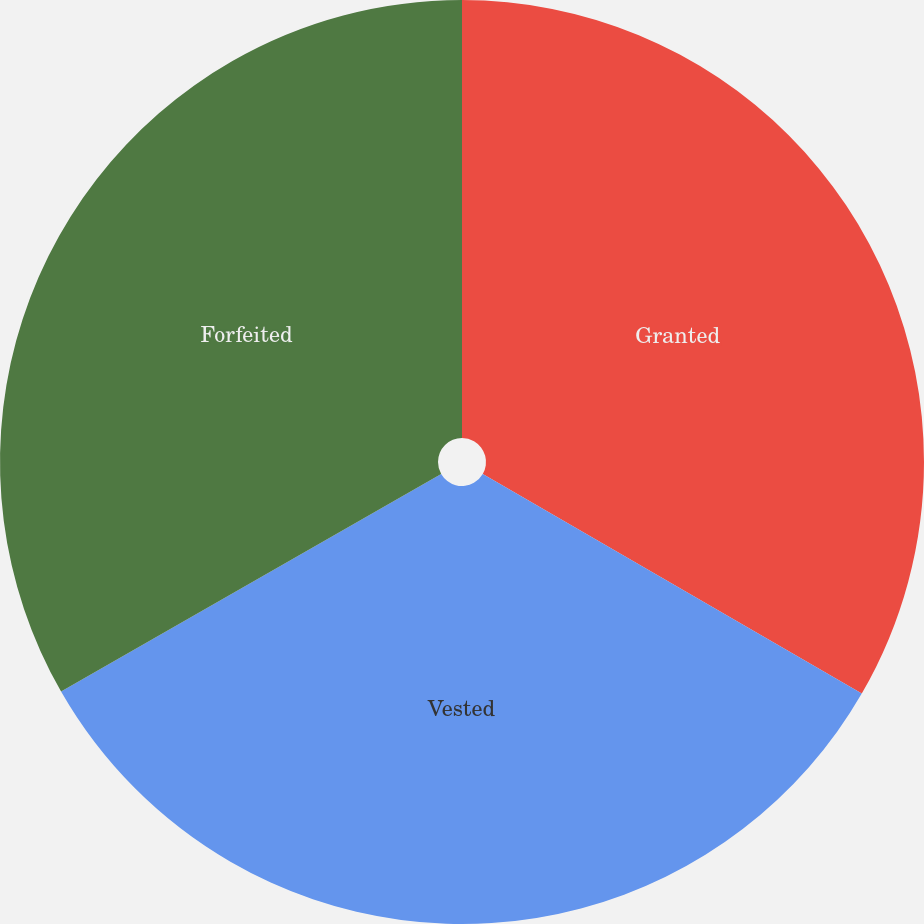Convert chart to OTSL. <chart><loc_0><loc_0><loc_500><loc_500><pie_chart><fcel>Granted<fcel>Vested<fcel>Forfeited<nl><fcel>33.36%<fcel>33.37%<fcel>33.28%<nl></chart> 